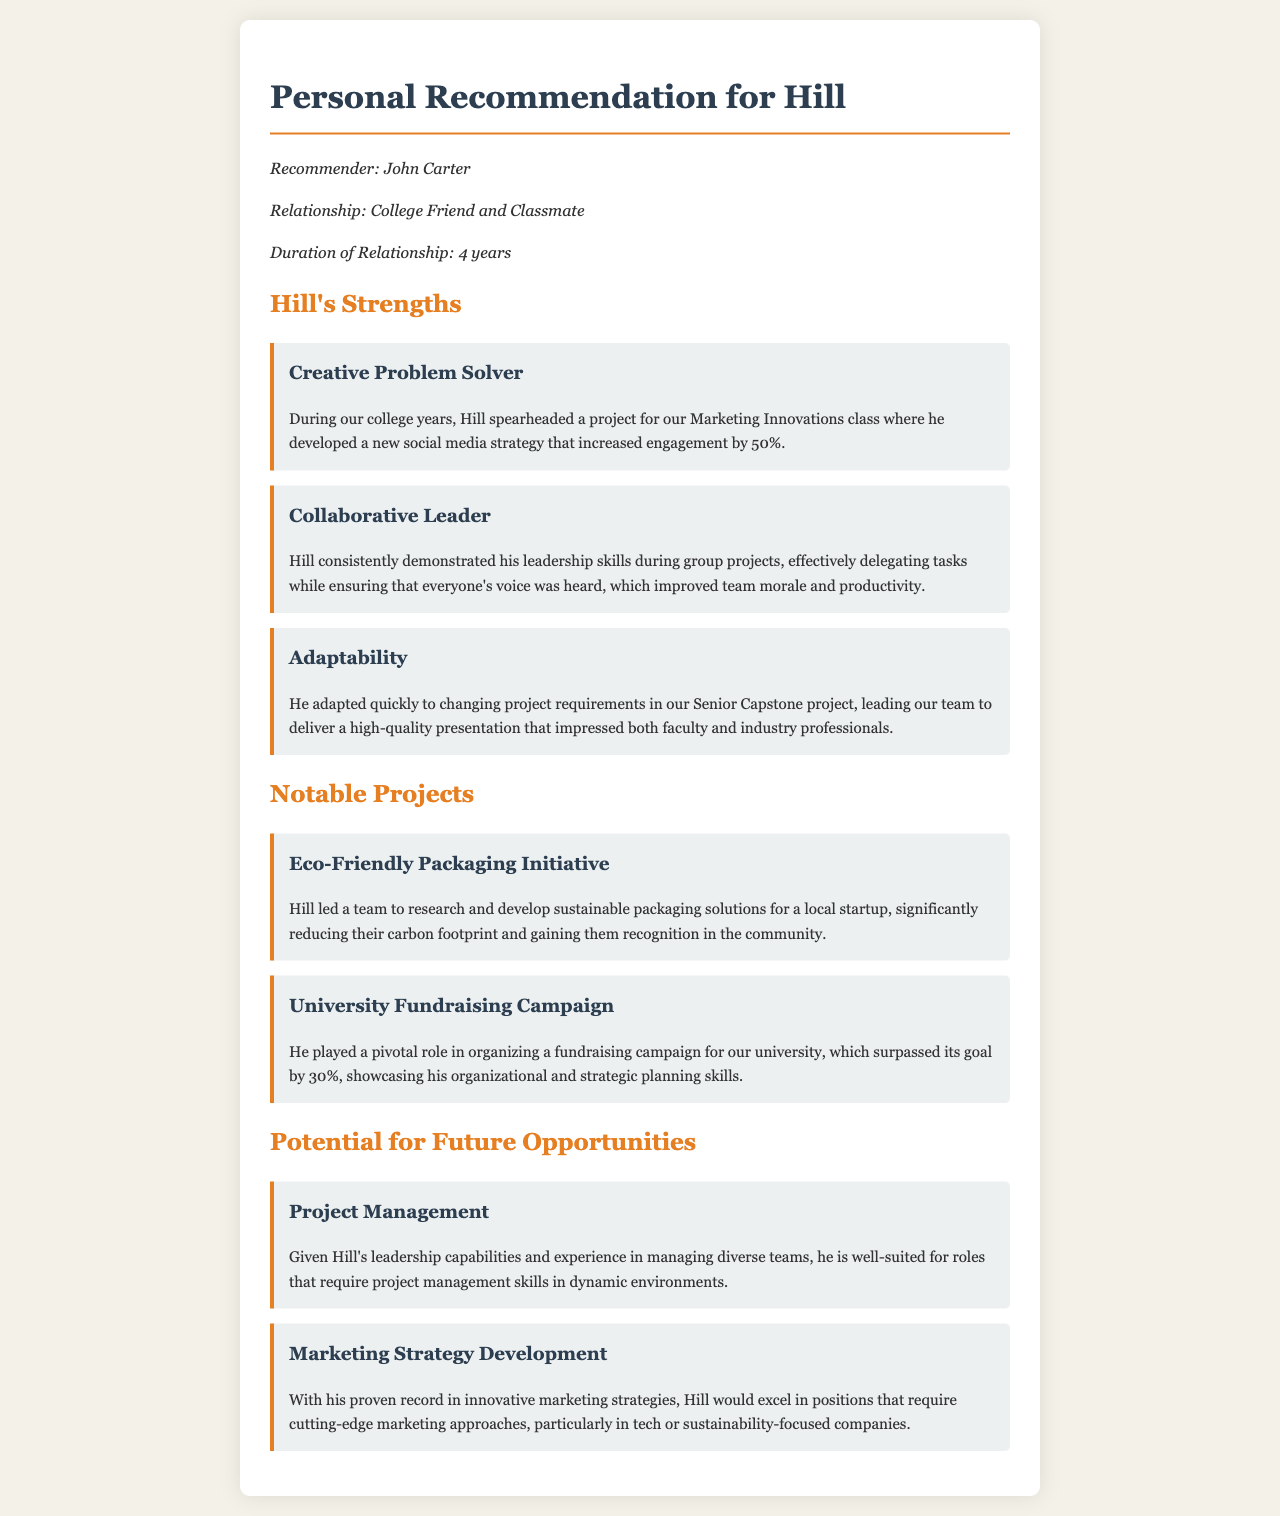what is the name of the recommender? The recommender's name is specified at the beginning of the document as John Carter.
Answer: John Carter how long has the recommender known Hill? The document states the duration of their relationship was 4 years.
Answer: 4 years what was one of Hill's strengths mentioned? The document lists multiple strengths, with "Creative Problem Solver" as one of them.
Answer: Creative Problem Solver what project did Hill lead related to sustainable practices? The Eco-Friendly Packaging Initiative is highlighted as a notable project led by Hill.
Answer: Eco-Friendly Packaging Initiative how much did the university fundraising campaign exceed its goal by? The fundraising campaign surpassed its goal by 30%, as mentioned in the relevant section.
Answer: 30% what role is Hill suited for according to the potential opportunities? The document mentions Hill is well-suited for project management roles.
Answer: Project Management which class did Hill develop a social media strategy for? Hill developed the social media strategy for the Marketing Innovations class.
Answer: Marketing Innovations class what is one area where Hill could excel in marketing? The document highlights that Hill could excel in tech or sustainability-focused companies.
Answer: tech or sustainability-focused companies how did Hill demonstrate his leadership skills during group projects? Hill effectively delegated tasks while ensuring everyone's voice was heard, improving team morale and productivity.
Answer: improving team morale and productivity 